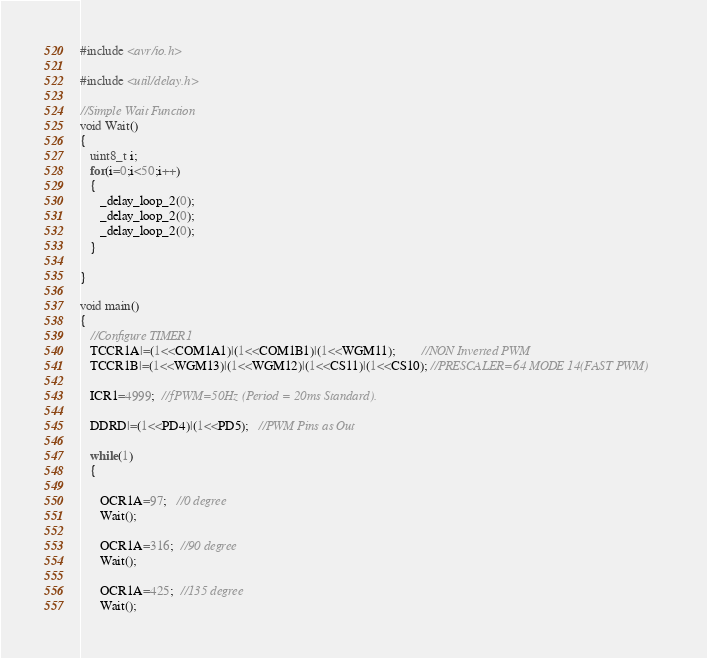<code> <loc_0><loc_0><loc_500><loc_500><_C_>#include <avr/io.h>

#include <util/delay.h>

//Simple Wait Function
void Wait()
{
   uint8_t i;
   for(i=0;i<50;i++)
   {
      _delay_loop_2(0);
      _delay_loop_2(0);
      _delay_loop_2(0);
   }

}

void main()
{
   //Configure TIMER1
   TCCR1A|=(1<<COM1A1)|(1<<COM1B1)|(1<<WGM11);        //NON Inverted PWM
   TCCR1B|=(1<<WGM13)|(1<<WGM12)|(1<<CS11)|(1<<CS10); //PRESCALER=64 MODE 14(FAST PWM)

   ICR1=4999;  //fPWM=50Hz (Period = 20ms Standard).

   DDRD|=(1<<PD4)|(1<<PD5);   //PWM Pins as Out

   while(1)
   {

      OCR1A=97;   //0 degree
      Wait();

      OCR1A=316;  //90 degree
      Wait();

      OCR1A=425;  //135 degree
      Wait();
</code> 